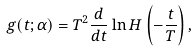Convert formula to latex. <formula><loc_0><loc_0><loc_500><loc_500>g ( t ; \alpha ) = T ^ { 2 } \frac { d } { d t } \ln H \left ( - \frac { t } { T } \right ) ,</formula> 